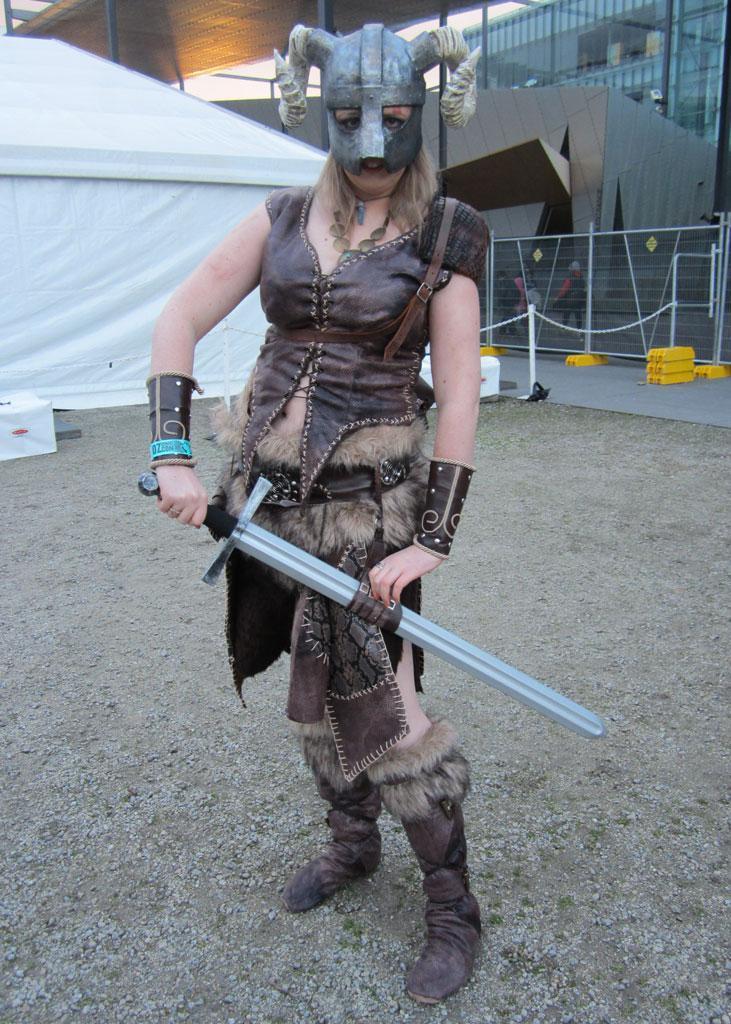Can you describe this image briefly? In this image I can see a woman is holding the sword, she wore leather top and leather shoes. She also wore a mask, on the right side it looks like a glass building, on the left side there is the tent. 